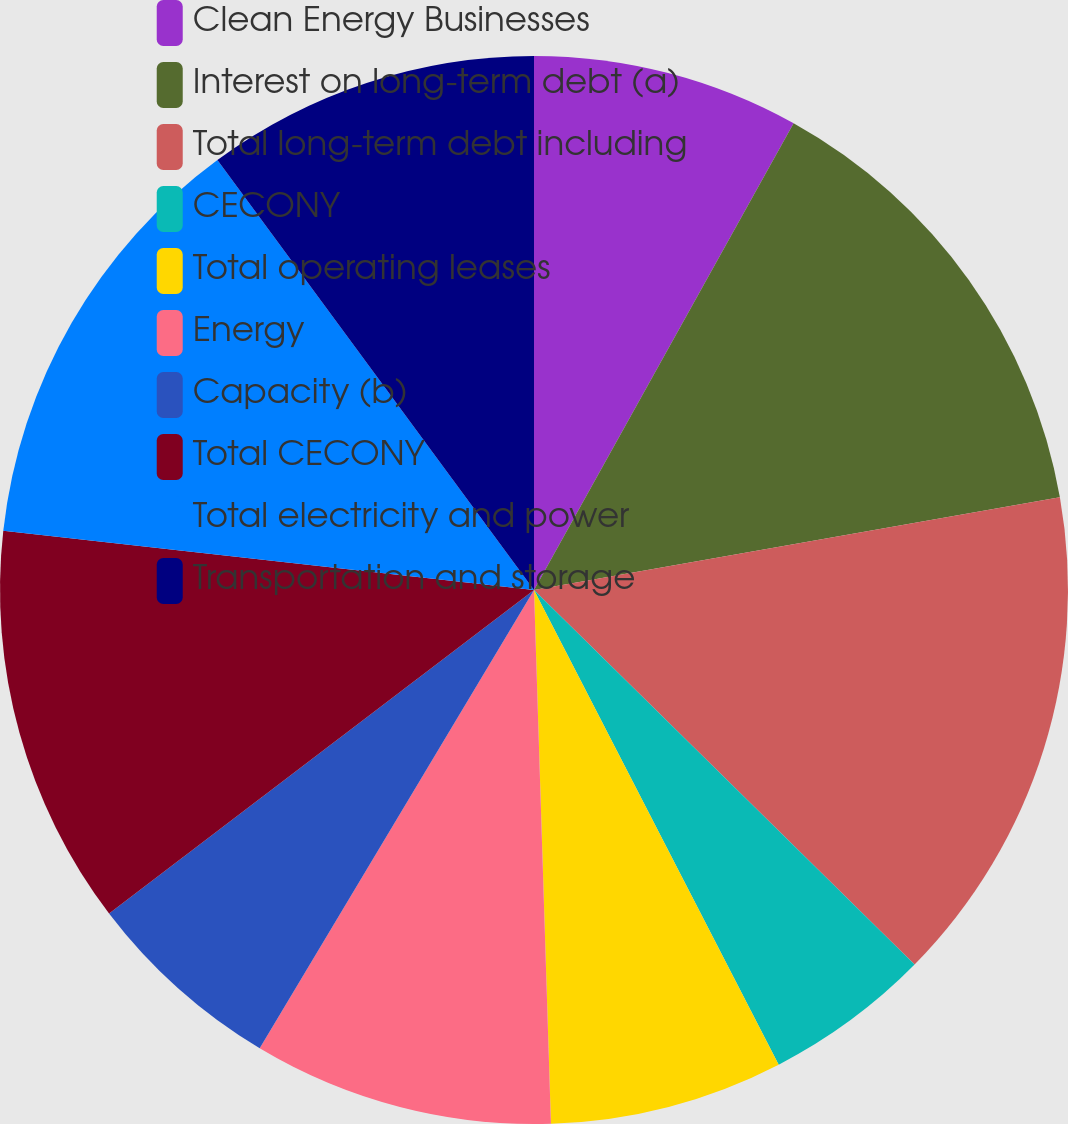Convert chart to OTSL. <chart><loc_0><loc_0><loc_500><loc_500><pie_chart><fcel>Clean Energy Businesses<fcel>Interest on long-term debt (a)<fcel>Total long-term debt including<fcel>CECONY<fcel>Total operating leases<fcel>Energy<fcel>Capacity (b)<fcel>Total CECONY<fcel>Total electricity and power<fcel>Transportation and storage<nl><fcel>8.08%<fcel>14.14%<fcel>15.15%<fcel>5.05%<fcel>7.07%<fcel>9.09%<fcel>6.06%<fcel>12.12%<fcel>13.13%<fcel>10.1%<nl></chart> 